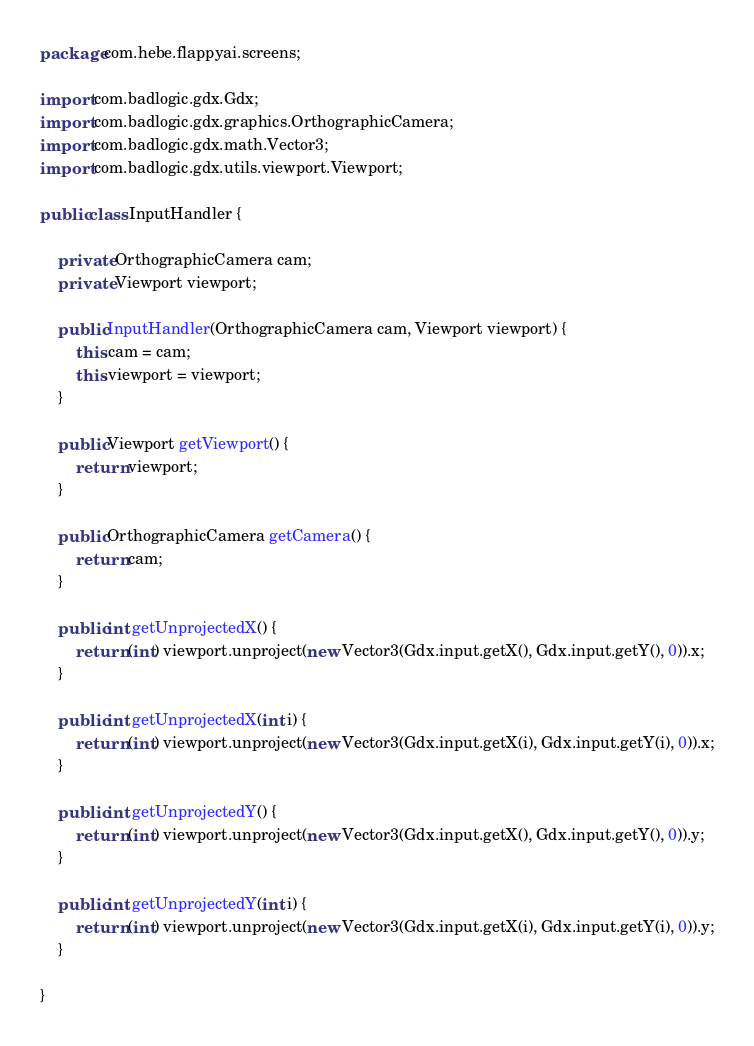<code> <loc_0><loc_0><loc_500><loc_500><_Java_>package com.hebe.flappyai.screens;

import com.badlogic.gdx.Gdx;
import com.badlogic.gdx.graphics.OrthographicCamera;
import com.badlogic.gdx.math.Vector3;
import com.badlogic.gdx.utils.viewport.Viewport;

public class InputHandler {

	private OrthographicCamera cam;
	private Viewport viewport;

	public InputHandler(OrthographicCamera cam, Viewport viewport) {
		this.cam = cam;
		this.viewport = viewport;
	}

	public Viewport getViewport() {
		return viewport;
	}

	public OrthographicCamera getCamera() {
		return cam;
	}

	public int getUnprojectedX() {
		return (int) viewport.unproject(new Vector3(Gdx.input.getX(), Gdx.input.getY(), 0)).x;
	}

	public int getUnprojectedX(int i) {
		return (int) viewport.unproject(new Vector3(Gdx.input.getX(i), Gdx.input.getY(i), 0)).x;
	}

	public int getUnprojectedY() {
		return (int) viewport.unproject(new Vector3(Gdx.input.getX(), Gdx.input.getY(), 0)).y;
	}

	public int getUnprojectedY(int i) {
		return (int) viewport.unproject(new Vector3(Gdx.input.getX(i), Gdx.input.getY(i), 0)).y;
	}

}
</code> 